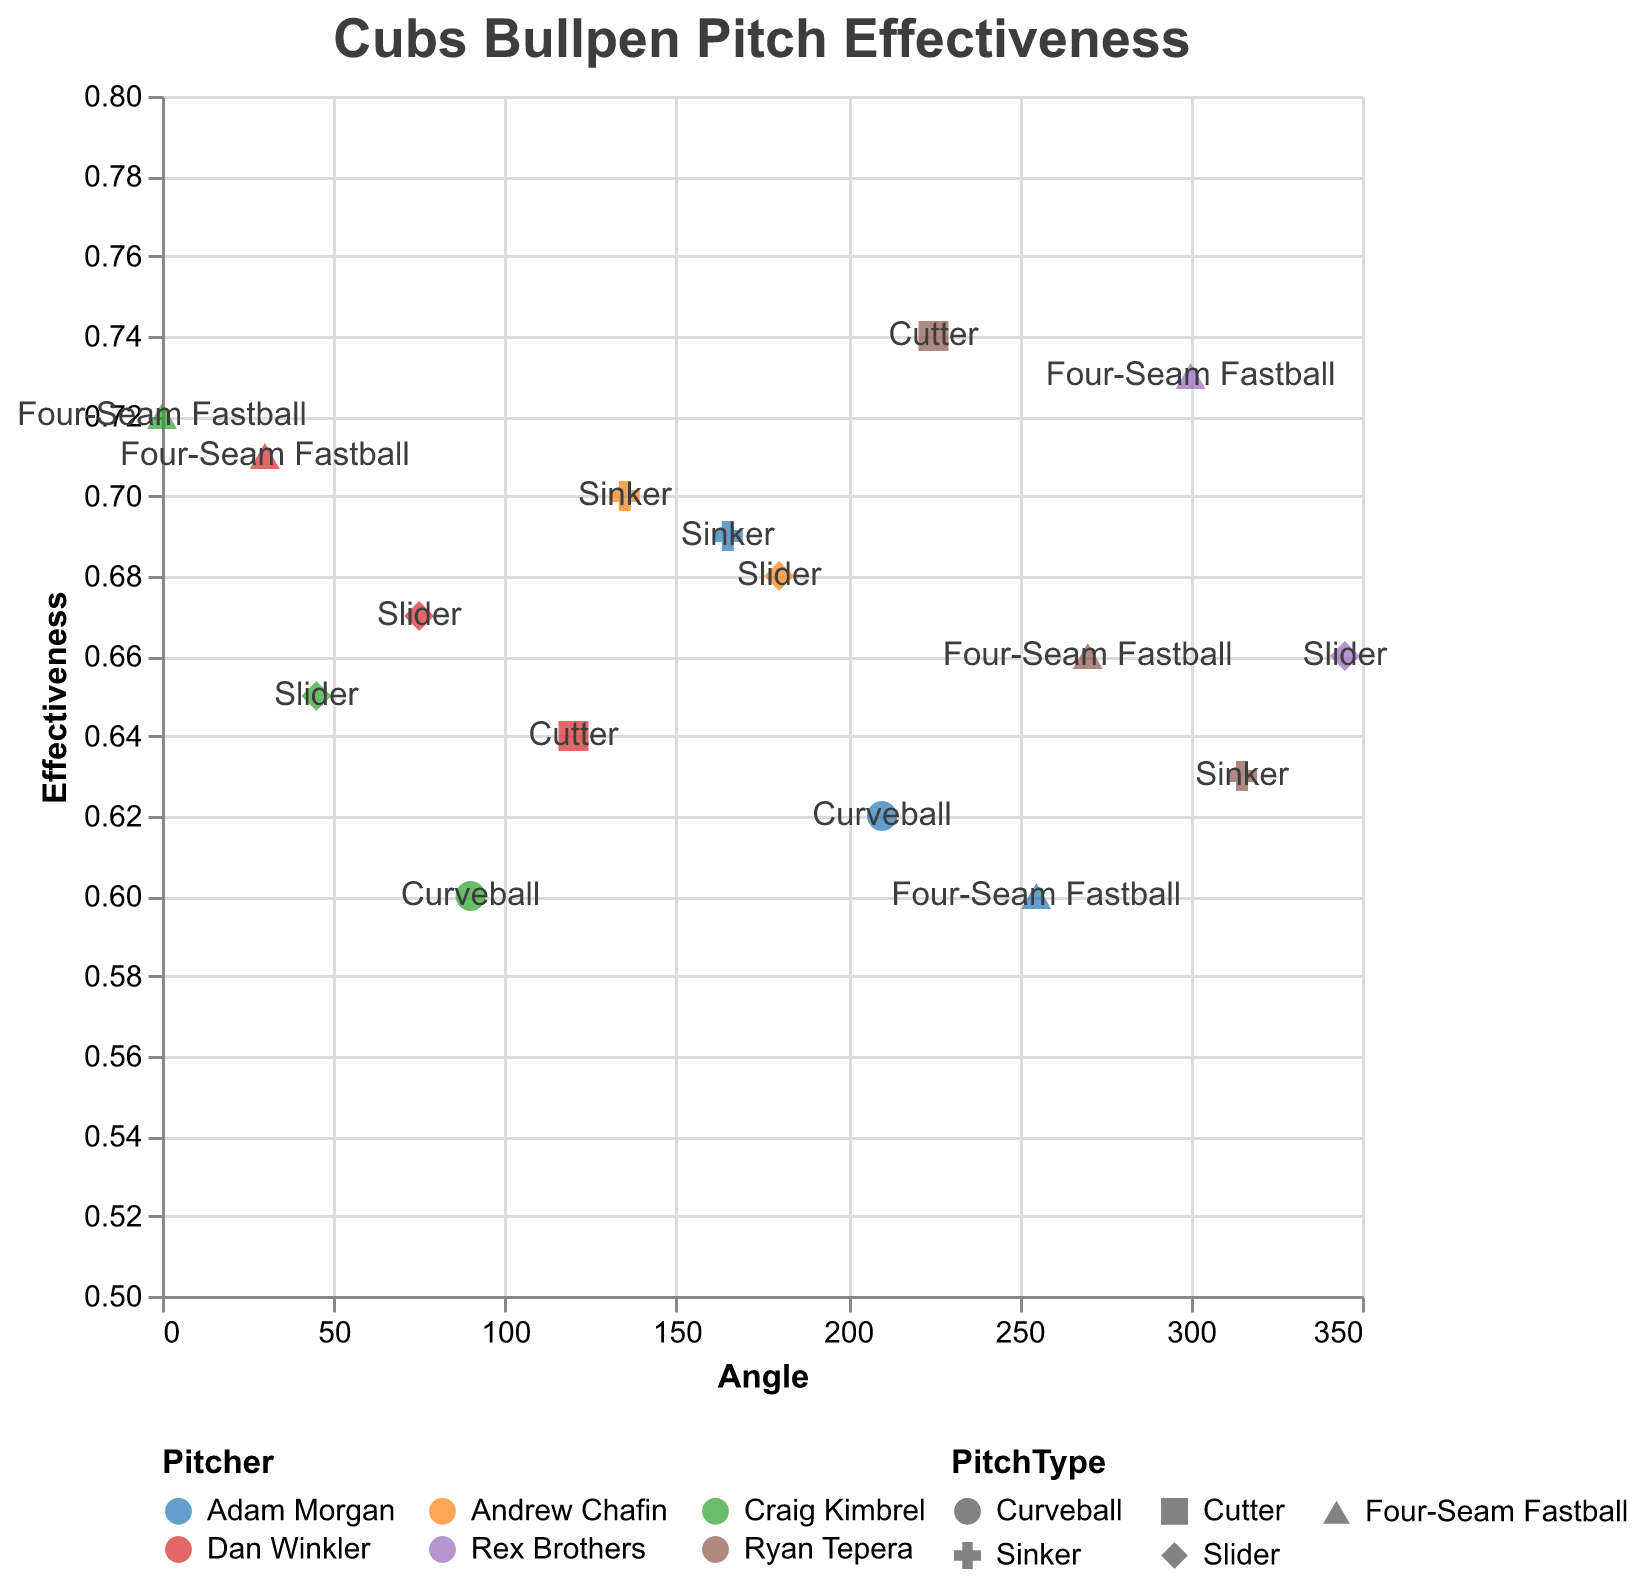Which pitcher has the highest effectiveness for a four-seam fastball? To determine the highest effectiveness for a four-seam fastball, look at the effectiveness values associated with this pitch type for all pitchers. Craig Kimbrel (0.72), Ryan Tepera (0.66), Dan Winkler (0.71), Adam Morgan (0.60), and Rex Brothers (0.73) each have a four-seam fastball, with Rex Brothers having the highest effectiveness.
Answer: Rex Brothers Which pitch type and pitcher pair has the lowest effectiveness on the chart? By reviewing the effectiveness values for each pitch type across all pitchers, Craig Kimbrel's curveball has the lowest effectiveness at 0.60.
Answer: Craig Kimbrel's curveball What's the combined effectiveness of all the sliders in the bullpen? To find the combined effectiveness, sum up all the effectiveness values for sliders: Craig Kimbrel (0.65), Andrew Chafin (0.68), Dan Winkler (0.67), Rex Brothers (0.66). Summing these values (0.65 + 0.68 + 0.67 + 0.66) gives a combined effectiveness of 2.66.
Answer: 2.66 How many pitchers use a curveball? To find the number of pitchers using a curveball, identify the distinct names associated with the curveball pitch type: Craig Kimbrel and Adam Morgan.
Answer: 2 Do any two pitchers have effectiveness values that are equal for any of their pitches? Checking the effectiveness values for equality among the pitchers, Craig Kimbrel's slider (0.65) matches neither Dan Winkler's slider (0.67) nor any others. No two pitchers have exactly matching effectiveness values for any pitch type.
Answer: No Which pitcher has the most diverse range of pitch types based on the chart? To determine the diversity of pitch types, count the number of unique pitch types for each pitcher: Craig Kimbrel (3), Andrew Chafin (2), Ryan Tepera (3), Dan Winkler (3), Adam Morgan (3), Rex Brothers (2). Craig Kimbrel, Ryan Tepera, Dan Winkler, and Adam Morgan each have 3 different pitch types.
Answer: Craig Kimbrel, Ryan Tepera, Dan Winkler, Adam Morgan Which pitch type has the highest median effectiveness value overall? To find this, gather the effectiveness values for each pitch type and calculate the median: Four-Seam Fastball (0.72, 0.66, 0.71, 0.60, 0.73), Slider (0.65, 0.68, 0.67, 0.66), Curveball (0.60, 0.62), Sinker (0.70, 0.63, 0.69), Cutter (0.74, 0.64). The medians are Four-Seam Fastball (0.71), Slider (0.665), Curveball (0.61), Sinker (0.69), and Cutter (0.69). The Four-Seam Fastball has the highest median.
Answer: Four-Seam Fastball 